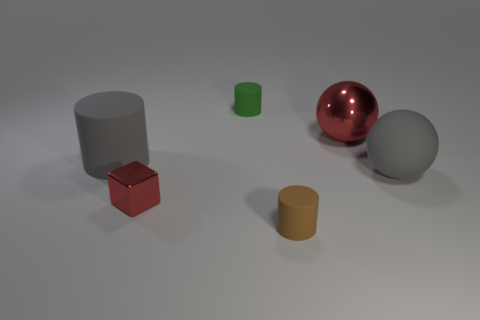Add 3 large cyan rubber blocks. How many objects exist? 9 Subtract all blocks. How many objects are left? 5 Subtract all purple shiny things. Subtract all big red balls. How many objects are left? 5 Add 4 small shiny cubes. How many small shiny cubes are left? 5 Add 6 cubes. How many cubes exist? 7 Subtract 0 green blocks. How many objects are left? 6 